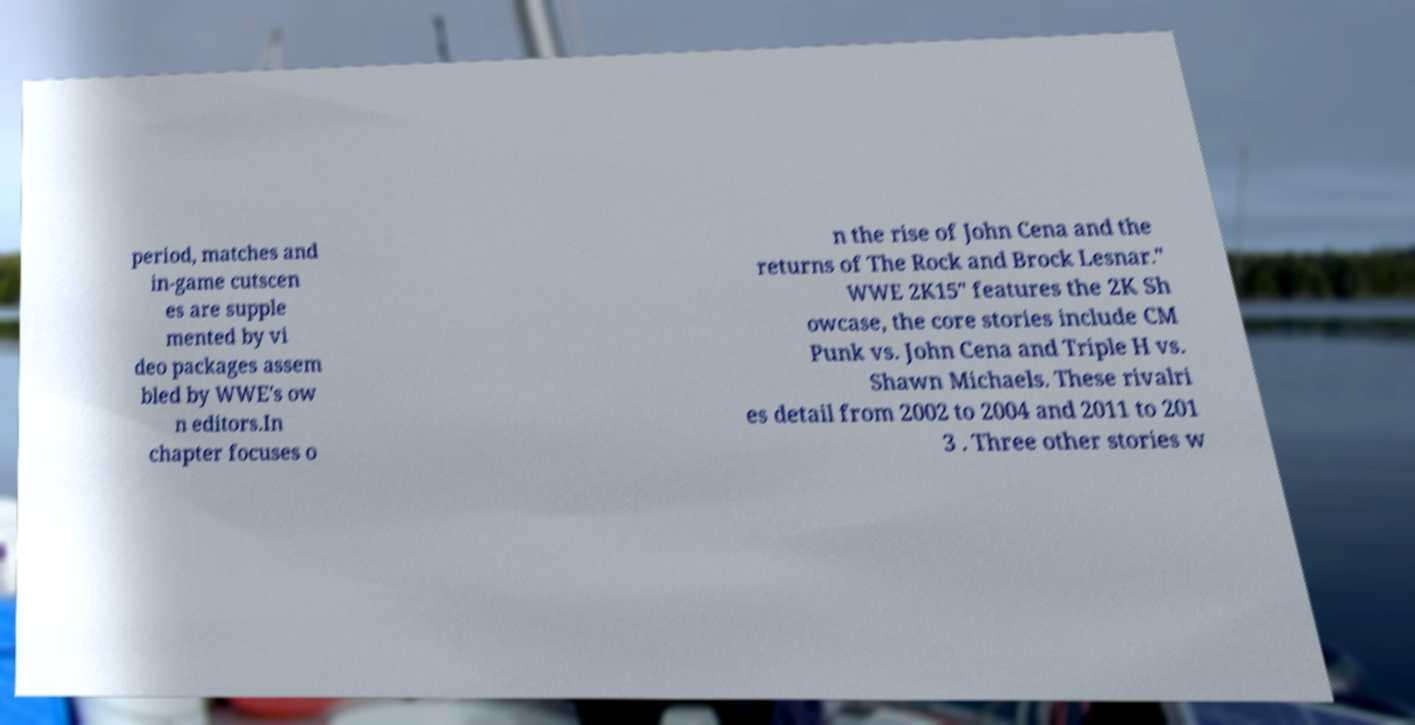Please read and relay the text visible in this image. What does it say? period, matches and in-game cutscen es are supple mented by vi deo packages assem bled by WWE's ow n editors.In chapter focuses o n the rise of John Cena and the returns of The Rock and Brock Lesnar." WWE 2K15" features the 2K Sh owcase, the core stories include CM Punk vs. John Cena and Triple H vs. Shawn Michaels. These rivalri es detail from 2002 to 2004 and 2011 to 201 3 . Three other stories w 